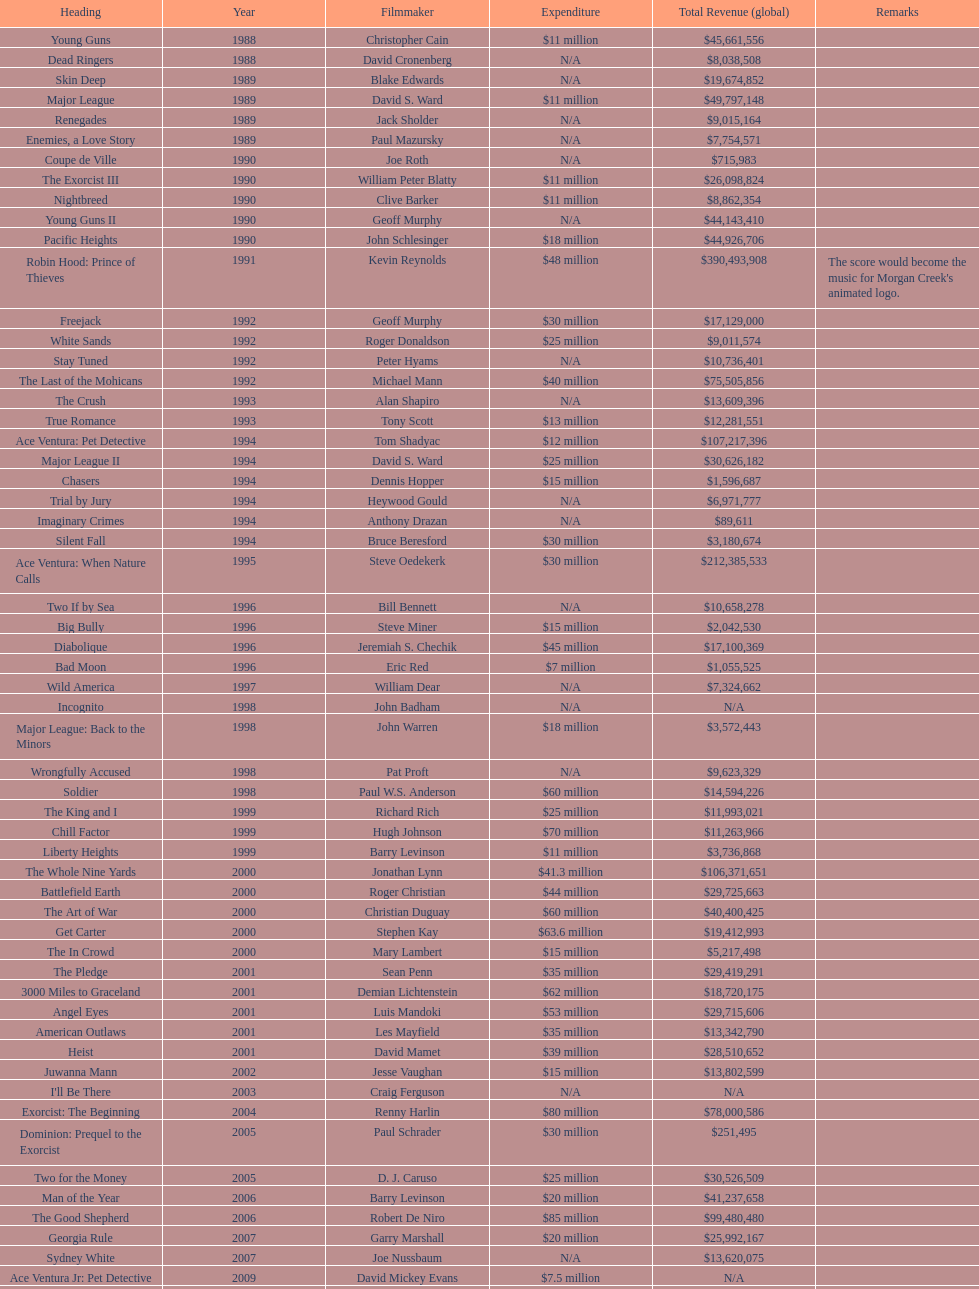How many films did morgan creek make in 2006? 2. 